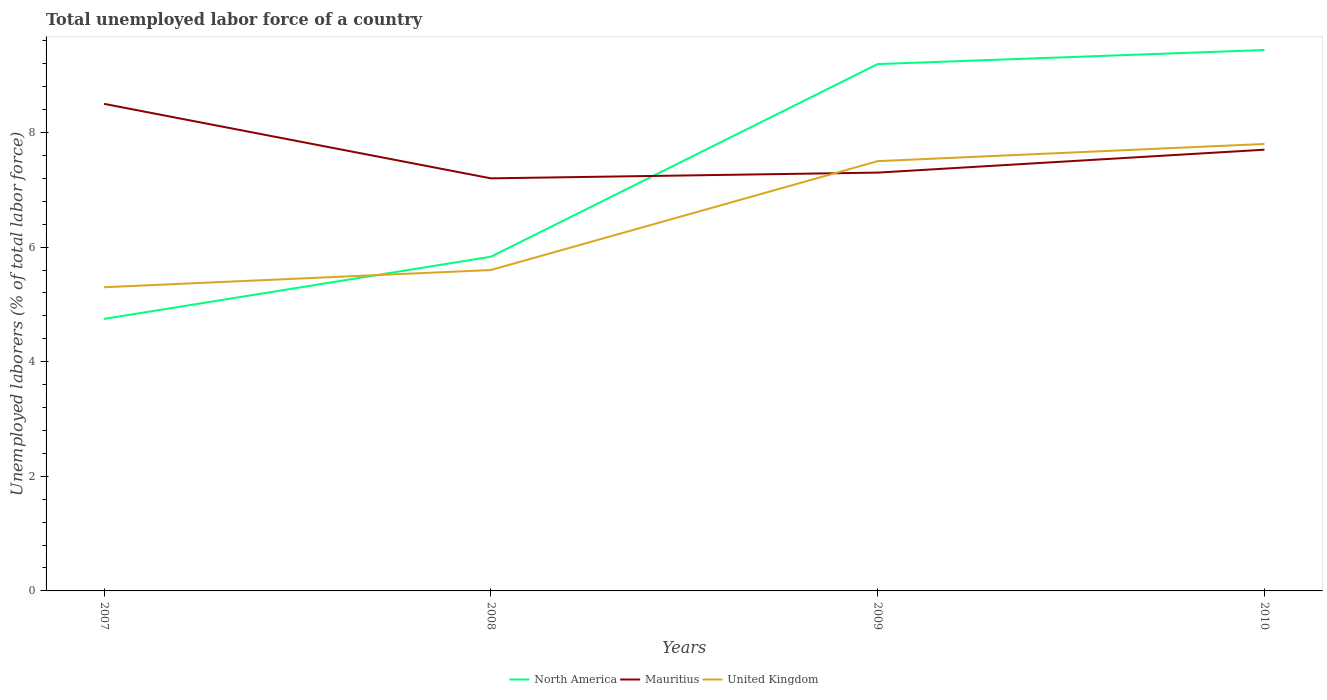Does the line corresponding to United Kingdom intersect with the line corresponding to North America?
Your answer should be compact. Yes. Is the number of lines equal to the number of legend labels?
Make the answer very short. Yes. Across all years, what is the maximum total unemployed labor force in North America?
Keep it short and to the point. 4.75. What is the total total unemployed labor force in North America in the graph?
Offer a very short reply. -4.45. What is the difference between the highest and the second highest total unemployed labor force in United Kingdom?
Ensure brevity in your answer.  2.5. Is the total unemployed labor force in United Kingdom strictly greater than the total unemployed labor force in Mauritius over the years?
Ensure brevity in your answer.  No. How many lines are there?
Your response must be concise. 3. How many years are there in the graph?
Keep it short and to the point. 4. What is the difference between two consecutive major ticks on the Y-axis?
Provide a succinct answer. 2. Does the graph contain any zero values?
Make the answer very short. No. Does the graph contain grids?
Your answer should be compact. No. How many legend labels are there?
Your answer should be compact. 3. What is the title of the graph?
Offer a terse response. Total unemployed labor force of a country. What is the label or title of the Y-axis?
Give a very brief answer. Unemployed laborers (% of total labor force). What is the Unemployed laborers (% of total labor force) in North America in 2007?
Provide a short and direct response. 4.75. What is the Unemployed laborers (% of total labor force) in Mauritius in 2007?
Make the answer very short. 8.5. What is the Unemployed laborers (% of total labor force) in United Kingdom in 2007?
Make the answer very short. 5.3. What is the Unemployed laborers (% of total labor force) of North America in 2008?
Provide a short and direct response. 5.83. What is the Unemployed laborers (% of total labor force) in Mauritius in 2008?
Provide a short and direct response. 7.2. What is the Unemployed laborers (% of total labor force) of United Kingdom in 2008?
Provide a succinct answer. 5.6. What is the Unemployed laborers (% of total labor force) of North America in 2009?
Your answer should be very brief. 9.19. What is the Unemployed laborers (% of total labor force) in Mauritius in 2009?
Keep it short and to the point. 7.3. What is the Unemployed laborers (% of total labor force) of United Kingdom in 2009?
Your answer should be compact. 7.5. What is the Unemployed laborers (% of total labor force) in North America in 2010?
Provide a succinct answer. 9.44. What is the Unemployed laborers (% of total labor force) in Mauritius in 2010?
Keep it short and to the point. 7.7. What is the Unemployed laborers (% of total labor force) in United Kingdom in 2010?
Keep it short and to the point. 7.8. Across all years, what is the maximum Unemployed laborers (% of total labor force) in North America?
Provide a short and direct response. 9.44. Across all years, what is the maximum Unemployed laborers (% of total labor force) in United Kingdom?
Your response must be concise. 7.8. Across all years, what is the minimum Unemployed laborers (% of total labor force) of North America?
Keep it short and to the point. 4.75. Across all years, what is the minimum Unemployed laborers (% of total labor force) of Mauritius?
Give a very brief answer. 7.2. Across all years, what is the minimum Unemployed laborers (% of total labor force) in United Kingdom?
Give a very brief answer. 5.3. What is the total Unemployed laborers (% of total labor force) in North America in the graph?
Offer a terse response. 29.21. What is the total Unemployed laborers (% of total labor force) in Mauritius in the graph?
Your response must be concise. 30.7. What is the total Unemployed laborers (% of total labor force) of United Kingdom in the graph?
Give a very brief answer. 26.2. What is the difference between the Unemployed laborers (% of total labor force) in North America in 2007 and that in 2008?
Keep it short and to the point. -1.08. What is the difference between the Unemployed laborers (% of total labor force) of Mauritius in 2007 and that in 2008?
Make the answer very short. 1.3. What is the difference between the Unemployed laborers (% of total labor force) of United Kingdom in 2007 and that in 2008?
Provide a short and direct response. -0.3. What is the difference between the Unemployed laborers (% of total labor force) of North America in 2007 and that in 2009?
Make the answer very short. -4.45. What is the difference between the Unemployed laborers (% of total labor force) in Mauritius in 2007 and that in 2009?
Give a very brief answer. 1.2. What is the difference between the Unemployed laborers (% of total labor force) in North America in 2007 and that in 2010?
Keep it short and to the point. -4.69. What is the difference between the Unemployed laborers (% of total labor force) of Mauritius in 2007 and that in 2010?
Provide a succinct answer. 0.8. What is the difference between the Unemployed laborers (% of total labor force) in United Kingdom in 2007 and that in 2010?
Your answer should be very brief. -2.5. What is the difference between the Unemployed laborers (% of total labor force) in North America in 2008 and that in 2009?
Keep it short and to the point. -3.36. What is the difference between the Unemployed laborers (% of total labor force) in North America in 2008 and that in 2010?
Give a very brief answer. -3.61. What is the difference between the Unemployed laborers (% of total labor force) of United Kingdom in 2008 and that in 2010?
Keep it short and to the point. -2.2. What is the difference between the Unemployed laborers (% of total labor force) in North America in 2009 and that in 2010?
Offer a very short reply. -0.25. What is the difference between the Unemployed laborers (% of total labor force) of Mauritius in 2009 and that in 2010?
Make the answer very short. -0.4. What is the difference between the Unemployed laborers (% of total labor force) of United Kingdom in 2009 and that in 2010?
Your response must be concise. -0.3. What is the difference between the Unemployed laborers (% of total labor force) in North America in 2007 and the Unemployed laborers (% of total labor force) in Mauritius in 2008?
Offer a very short reply. -2.45. What is the difference between the Unemployed laborers (% of total labor force) in North America in 2007 and the Unemployed laborers (% of total labor force) in United Kingdom in 2008?
Your answer should be very brief. -0.85. What is the difference between the Unemployed laborers (% of total labor force) in North America in 2007 and the Unemployed laborers (% of total labor force) in Mauritius in 2009?
Give a very brief answer. -2.55. What is the difference between the Unemployed laborers (% of total labor force) of North America in 2007 and the Unemployed laborers (% of total labor force) of United Kingdom in 2009?
Make the answer very short. -2.75. What is the difference between the Unemployed laborers (% of total labor force) in Mauritius in 2007 and the Unemployed laborers (% of total labor force) in United Kingdom in 2009?
Keep it short and to the point. 1. What is the difference between the Unemployed laborers (% of total labor force) of North America in 2007 and the Unemployed laborers (% of total labor force) of Mauritius in 2010?
Offer a terse response. -2.95. What is the difference between the Unemployed laborers (% of total labor force) of North America in 2007 and the Unemployed laborers (% of total labor force) of United Kingdom in 2010?
Your answer should be very brief. -3.05. What is the difference between the Unemployed laborers (% of total labor force) in Mauritius in 2007 and the Unemployed laborers (% of total labor force) in United Kingdom in 2010?
Ensure brevity in your answer.  0.7. What is the difference between the Unemployed laborers (% of total labor force) in North America in 2008 and the Unemployed laborers (% of total labor force) in Mauritius in 2009?
Your answer should be compact. -1.47. What is the difference between the Unemployed laborers (% of total labor force) of North America in 2008 and the Unemployed laborers (% of total labor force) of United Kingdom in 2009?
Give a very brief answer. -1.67. What is the difference between the Unemployed laborers (% of total labor force) in North America in 2008 and the Unemployed laborers (% of total labor force) in Mauritius in 2010?
Your answer should be compact. -1.87. What is the difference between the Unemployed laborers (% of total labor force) in North America in 2008 and the Unemployed laborers (% of total labor force) in United Kingdom in 2010?
Your answer should be very brief. -1.97. What is the difference between the Unemployed laborers (% of total labor force) of North America in 2009 and the Unemployed laborers (% of total labor force) of Mauritius in 2010?
Make the answer very short. 1.49. What is the difference between the Unemployed laborers (% of total labor force) in North America in 2009 and the Unemployed laborers (% of total labor force) in United Kingdom in 2010?
Provide a succinct answer. 1.39. What is the difference between the Unemployed laborers (% of total labor force) in Mauritius in 2009 and the Unemployed laborers (% of total labor force) in United Kingdom in 2010?
Your response must be concise. -0.5. What is the average Unemployed laborers (% of total labor force) of North America per year?
Your answer should be very brief. 7.3. What is the average Unemployed laborers (% of total labor force) in Mauritius per year?
Provide a short and direct response. 7.67. What is the average Unemployed laborers (% of total labor force) in United Kingdom per year?
Your response must be concise. 6.55. In the year 2007, what is the difference between the Unemployed laborers (% of total labor force) in North America and Unemployed laborers (% of total labor force) in Mauritius?
Provide a succinct answer. -3.75. In the year 2007, what is the difference between the Unemployed laborers (% of total labor force) in North America and Unemployed laborers (% of total labor force) in United Kingdom?
Your response must be concise. -0.55. In the year 2008, what is the difference between the Unemployed laborers (% of total labor force) of North America and Unemployed laborers (% of total labor force) of Mauritius?
Make the answer very short. -1.37. In the year 2008, what is the difference between the Unemployed laborers (% of total labor force) in North America and Unemployed laborers (% of total labor force) in United Kingdom?
Your answer should be compact. 0.23. In the year 2008, what is the difference between the Unemployed laborers (% of total labor force) in Mauritius and Unemployed laborers (% of total labor force) in United Kingdom?
Provide a succinct answer. 1.6. In the year 2009, what is the difference between the Unemployed laborers (% of total labor force) of North America and Unemployed laborers (% of total labor force) of Mauritius?
Ensure brevity in your answer.  1.89. In the year 2009, what is the difference between the Unemployed laborers (% of total labor force) in North America and Unemployed laborers (% of total labor force) in United Kingdom?
Your answer should be compact. 1.69. In the year 2010, what is the difference between the Unemployed laborers (% of total labor force) of North America and Unemployed laborers (% of total labor force) of Mauritius?
Your answer should be compact. 1.74. In the year 2010, what is the difference between the Unemployed laborers (% of total labor force) of North America and Unemployed laborers (% of total labor force) of United Kingdom?
Offer a terse response. 1.64. In the year 2010, what is the difference between the Unemployed laborers (% of total labor force) of Mauritius and Unemployed laborers (% of total labor force) of United Kingdom?
Keep it short and to the point. -0.1. What is the ratio of the Unemployed laborers (% of total labor force) of North America in 2007 to that in 2008?
Provide a succinct answer. 0.81. What is the ratio of the Unemployed laborers (% of total labor force) in Mauritius in 2007 to that in 2008?
Offer a terse response. 1.18. What is the ratio of the Unemployed laborers (% of total labor force) in United Kingdom in 2007 to that in 2008?
Offer a terse response. 0.95. What is the ratio of the Unemployed laborers (% of total labor force) in North America in 2007 to that in 2009?
Offer a very short reply. 0.52. What is the ratio of the Unemployed laborers (% of total labor force) in Mauritius in 2007 to that in 2009?
Give a very brief answer. 1.16. What is the ratio of the Unemployed laborers (% of total labor force) of United Kingdom in 2007 to that in 2009?
Give a very brief answer. 0.71. What is the ratio of the Unemployed laborers (% of total labor force) of North America in 2007 to that in 2010?
Your answer should be compact. 0.5. What is the ratio of the Unemployed laborers (% of total labor force) in Mauritius in 2007 to that in 2010?
Make the answer very short. 1.1. What is the ratio of the Unemployed laborers (% of total labor force) of United Kingdom in 2007 to that in 2010?
Offer a very short reply. 0.68. What is the ratio of the Unemployed laborers (% of total labor force) of North America in 2008 to that in 2009?
Offer a terse response. 0.63. What is the ratio of the Unemployed laborers (% of total labor force) of Mauritius in 2008 to that in 2009?
Your answer should be very brief. 0.99. What is the ratio of the Unemployed laborers (% of total labor force) in United Kingdom in 2008 to that in 2009?
Offer a very short reply. 0.75. What is the ratio of the Unemployed laborers (% of total labor force) of North America in 2008 to that in 2010?
Give a very brief answer. 0.62. What is the ratio of the Unemployed laborers (% of total labor force) in Mauritius in 2008 to that in 2010?
Your answer should be very brief. 0.94. What is the ratio of the Unemployed laborers (% of total labor force) in United Kingdom in 2008 to that in 2010?
Your response must be concise. 0.72. What is the ratio of the Unemployed laborers (% of total labor force) in Mauritius in 2009 to that in 2010?
Your answer should be compact. 0.95. What is the ratio of the Unemployed laborers (% of total labor force) of United Kingdom in 2009 to that in 2010?
Your response must be concise. 0.96. What is the difference between the highest and the second highest Unemployed laborers (% of total labor force) in North America?
Make the answer very short. 0.25. What is the difference between the highest and the second highest Unemployed laborers (% of total labor force) in United Kingdom?
Make the answer very short. 0.3. What is the difference between the highest and the lowest Unemployed laborers (% of total labor force) in North America?
Your response must be concise. 4.69. 